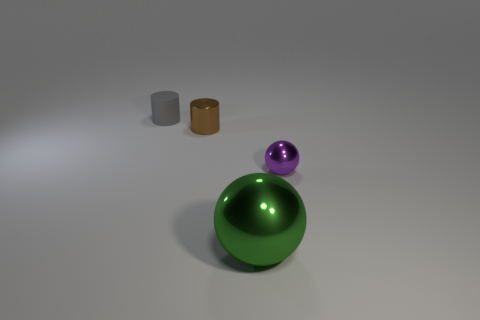There is a green object that is the same material as the brown object; what is its shape?
Provide a short and direct response. Sphere. What is the tiny thing in front of the brown metal cylinder made of?
Provide a succinct answer. Metal. There is a object to the right of the green sphere; is its size the same as the thing that is behind the tiny brown cylinder?
Provide a short and direct response. Yes. What is the color of the rubber object?
Offer a terse response. Gray. There is a small object that is behind the small brown metallic cylinder; is it the same shape as the big thing?
Make the answer very short. No. What material is the green ball?
Make the answer very short. Metal. What shape is the purple metallic object that is the same size as the matte thing?
Your response must be concise. Sphere. What color is the metallic ball in front of the tiny thing that is in front of the small brown object?
Give a very brief answer. Green. Is there a metallic cylinder to the left of the cylinder that is left of the tiny metallic thing that is left of the purple ball?
Offer a very short reply. No. There is a cylinder that is made of the same material as the small sphere; what color is it?
Give a very brief answer. Brown. 